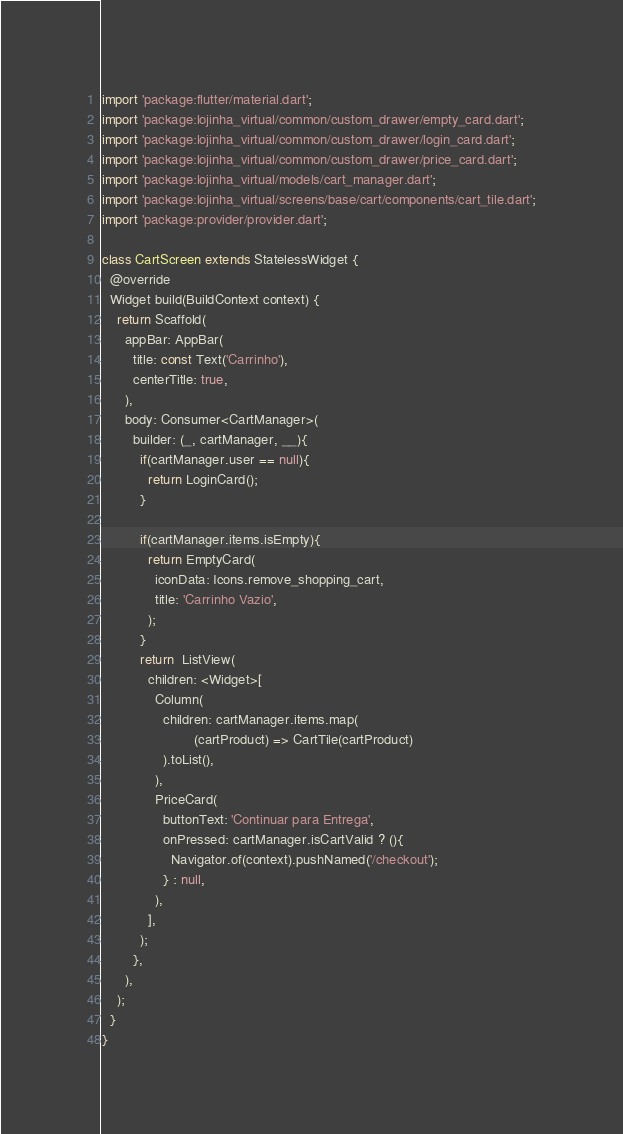Convert code to text. <code><loc_0><loc_0><loc_500><loc_500><_Dart_>import 'package:flutter/material.dart';
import 'package:lojinha_virtual/common/custom_drawer/empty_card.dart';
import 'package:lojinha_virtual/common/custom_drawer/login_card.dart';
import 'package:lojinha_virtual/common/custom_drawer/price_card.dart';
import 'package:lojinha_virtual/models/cart_manager.dart';
import 'package:lojinha_virtual/screens/base/cart/components/cart_tile.dart';
import 'package:provider/provider.dart';

class CartScreen extends StatelessWidget {
  @override
  Widget build(BuildContext context) {
    return Scaffold(
      appBar: AppBar(
        title: const Text('Carrinho'),
        centerTitle: true,
      ),
      body: Consumer<CartManager>(
        builder: (_, cartManager, __){
          if(cartManager.user == null){
            return LoginCard();
          }

          if(cartManager.items.isEmpty){
            return EmptyCard(
              iconData: Icons.remove_shopping_cart,
              title: 'Carrinho Vazio',
            );
          }
          return  ListView(
            children: <Widget>[
              Column(
                children: cartManager.items.map(
                        (cartProduct) => CartTile(cartProduct)
                ).toList(),
              ),
              PriceCard(
                buttonText: 'Continuar para Entrega',
                onPressed: cartManager.isCartValid ? (){
                  Navigator.of(context).pushNamed('/checkout');
                } : null,
              ),
            ],
          );
        },
      ),
    );
  }
}</code> 